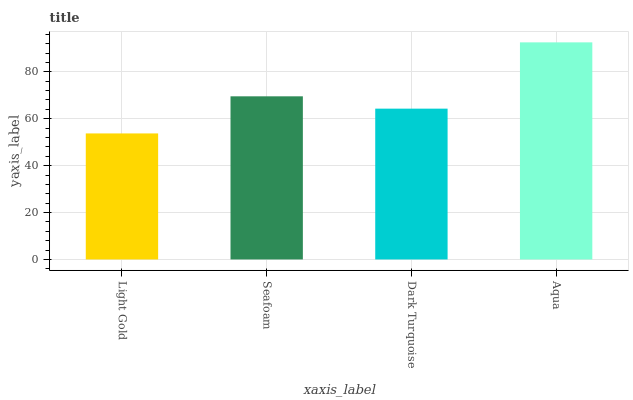Is Seafoam the minimum?
Answer yes or no. No. Is Seafoam the maximum?
Answer yes or no. No. Is Seafoam greater than Light Gold?
Answer yes or no. Yes. Is Light Gold less than Seafoam?
Answer yes or no. Yes. Is Light Gold greater than Seafoam?
Answer yes or no. No. Is Seafoam less than Light Gold?
Answer yes or no. No. Is Seafoam the high median?
Answer yes or no. Yes. Is Dark Turquoise the low median?
Answer yes or no. Yes. Is Light Gold the high median?
Answer yes or no. No. Is Seafoam the low median?
Answer yes or no. No. 